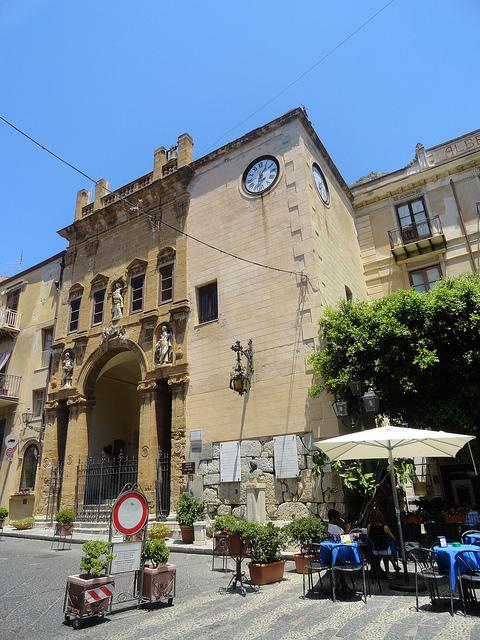How many clock faces?
Be succinct. 2. What are the people under the umbrella doing?
Concise answer only. Eating. How many people can be seen in the picture?
Quick response, please. 3. 